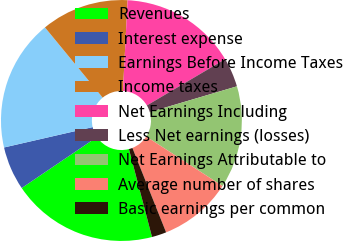Convert chart to OTSL. <chart><loc_0><loc_0><loc_500><loc_500><pie_chart><fcel>Revenues<fcel>Interest expense<fcel>Earnings Before Income Taxes<fcel>Income taxes<fcel>Net Earnings Including<fcel>Less Net earnings (losses)<fcel>Net Earnings Attributable to<fcel>Average number of shares<fcel>Basic earnings per common<nl><fcel>19.61%<fcel>5.88%<fcel>17.65%<fcel>11.76%<fcel>15.69%<fcel>3.92%<fcel>13.73%<fcel>9.8%<fcel>1.96%<nl></chart> 